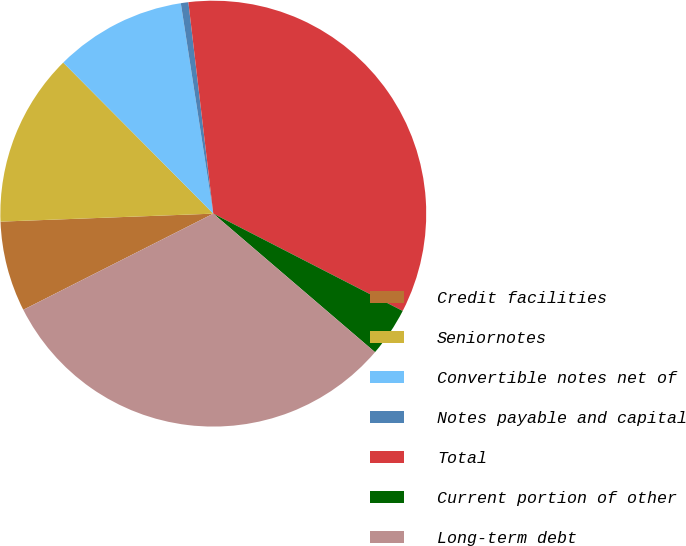Convert chart. <chart><loc_0><loc_0><loc_500><loc_500><pie_chart><fcel>Credit facilities<fcel>Seniornotes<fcel>Convertible notes net of<fcel>Notes payable and capital<fcel>Total<fcel>Current portion of other<fcel>Long-term debt<nl><fcel>6.86%<fcel>13.15%<fcel>10.01%<fcel>0.57%<fcel>34.42%<fcel>3.72%<fcel>31.27%<nl></chart> 